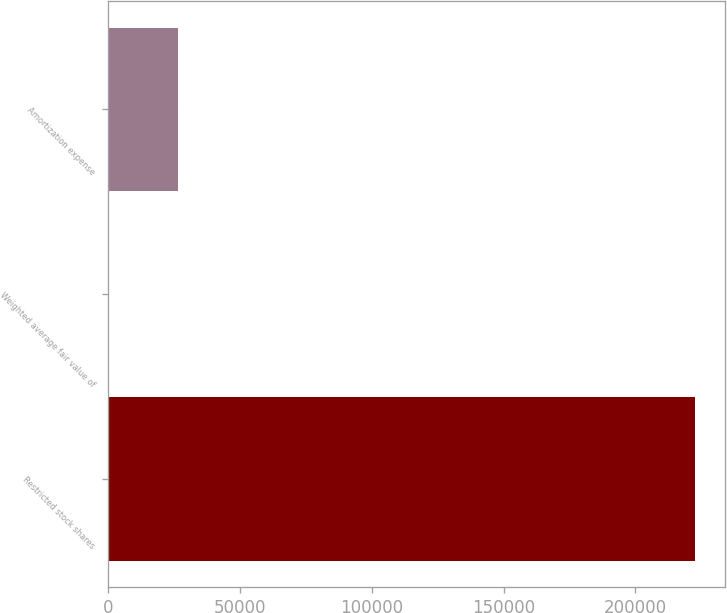<chart> <loc_0><loc_0><loc_500><loc_500><bar_chart><fcel>Restricted stock shares<fcel>Weighted average fair value of<fcel>Amortization expense<nl><fcel>222725<fcel>120.55<fcel>26779<nl></chart> 